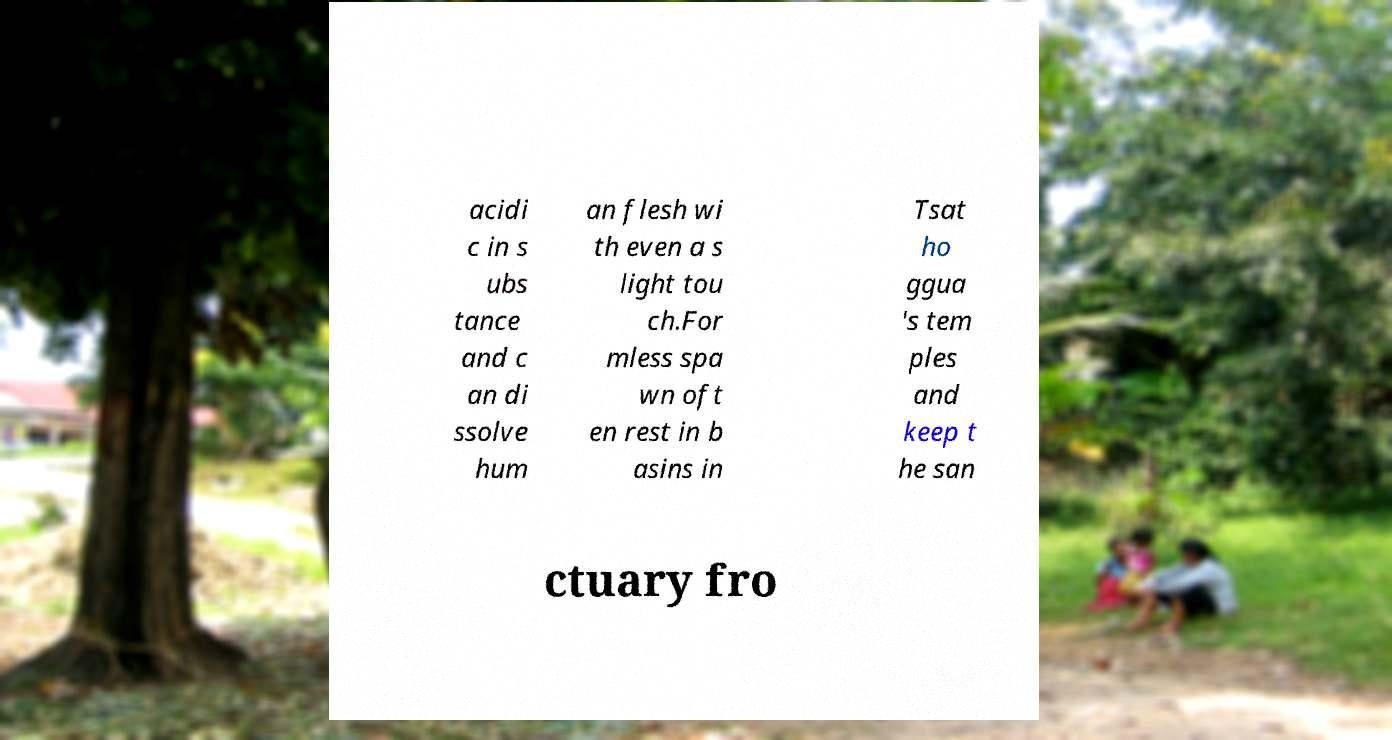Could you extract and type out the text from this image? acidi c in s ubs tance and c an di ssolve hum an flesh wi th even a s light tou ch.For mless spa wn oft en rest in b asins in Tsat ho ggua 's tem ples and keep t he san ctuary fro 